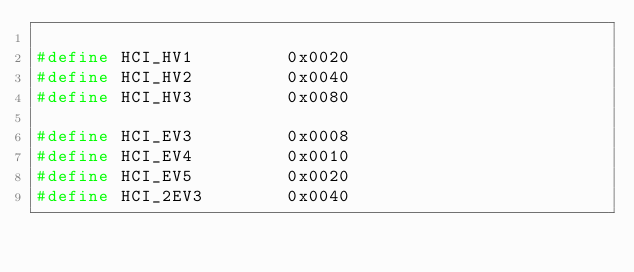Convert code to text. <code><loc_0><loc_0><loc_500><loc_500><_C_>
#define HCI_HV1         0x0020
#define HCI_HV2         0x0040
#define HCI_HV3         0x0080

#define HCI_EV3         0x0008
#define HCI_EV4         0x0010
#define HCI_EV5         0x0020
#define HCI_2EV3        0x0040</code> 